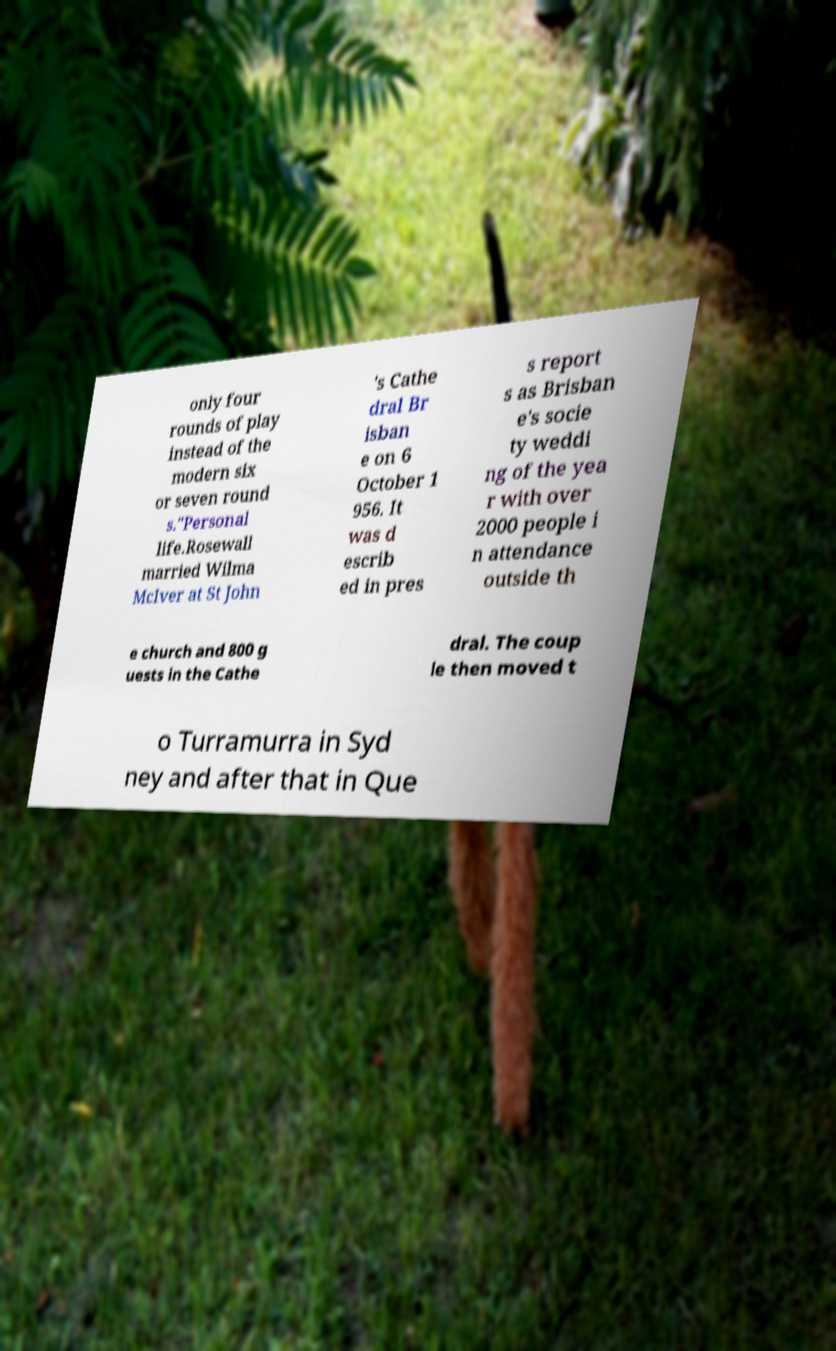What messages or text are displayed in this image? I need them in a readable, typed format. only four rounds of play instead of the modern six or seven round s."Personal life.Rosewall married Wilma McIver at St John 's Cathe dral Br isban e on 6 October 1 956. It was d escrib ed in pres s report s as Brisban e's socie ty weddi ng of the yea r with over 2000 people i n attendance outside th e church and 800 g uests in the Cathe dral. The coup le then moved t o Turramurra in Syd ney and after that in Que 